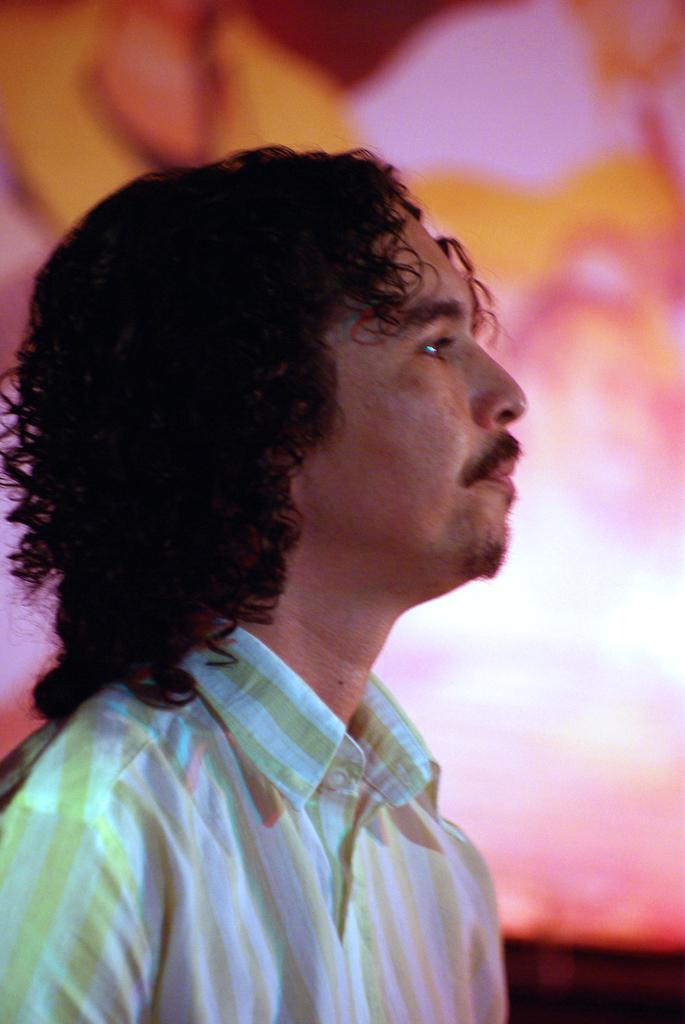In one or two sentences, can you explain what this image depicts? In this image, we can see a person wearing clothes on the blur background. 